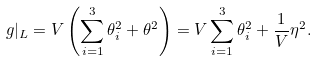Convert formula to latex. <formula><loc_0><loc_0><loc_500><loc_500>g | _ { L } = V \left ( \sum _ { i = 1 } ^ { 3 } \theta _ { i } ^ { 2 } + \theta ^ { 2 } \right ) = V \sum _ { i = 1 } ^ { 3 } \theta _ { i } ^ { 2 } + \frac { 1 } { V } \eta ^ { 2 } .</formula> 